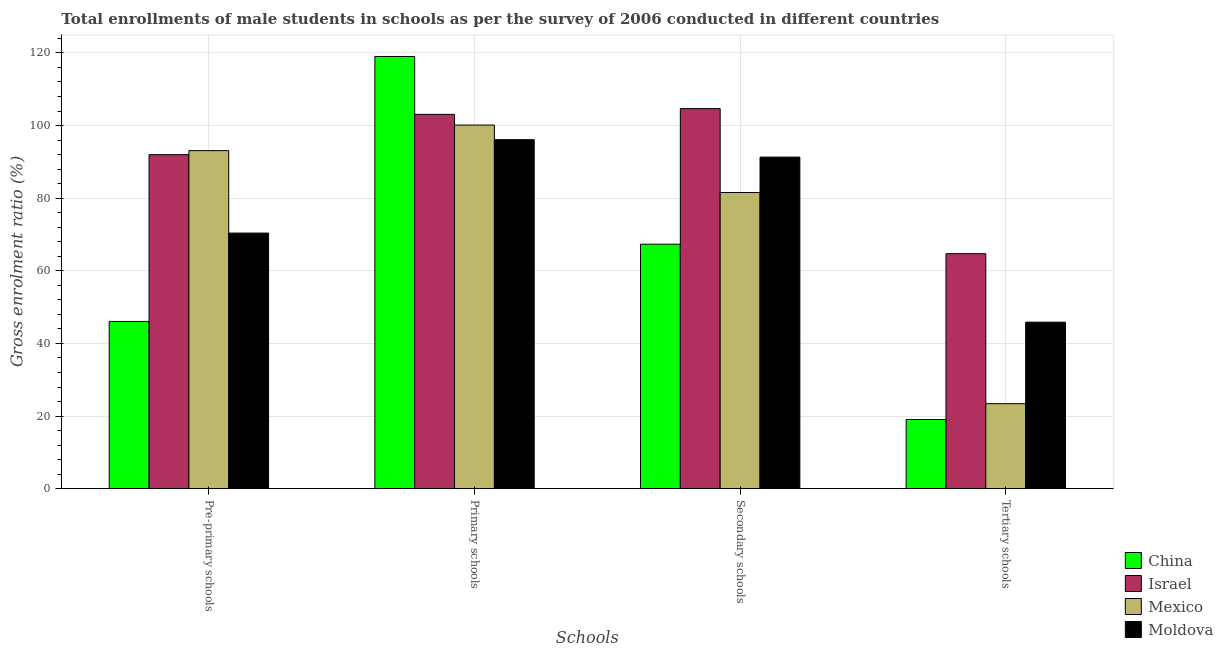How many different coloured bars are there?
Your answer should be compact. 4. How many groups of bars are there?
Keep it short and to the point. 4. Are the number of bars per tick equal to the number of legend labels?
Your answer should be very brief. Yes. Are the number of bars on each tick of the X-axis equal?
Keep it short and to the point. Yes. How many bars are there on the 4th tick from the right?
Ensure brevity in your answer.  4. What is the label of the 3rd group of bars from the left?
Your response must be concise. Secondary schools. What is the gross enrolment ratio(male) in pre-primary schools in China?
Your answer should be compact. 46.05. Across all countries, what is the maximum gross enrolment ratio(male) in primary schools?
Offer a very short reply. 119.02. Across all countries, what is the minimum gross enrolment ratio(male) in tertiary schools?
Offer a terse response. 19.05. What is the total gross enrolment ratio(male) in secondary schools in the graph?
Offer a very short reply. 344.88. What is the difference between the gross enrolment ratio(male) in pre-primary schools in Mexico and that in China?
Make the answer very short. 47.04. What is the difference between the gross enrolment ratio(male) in primary schools in Israel and the gross enrolment ratio(male) in tertiary schools in China?
Your response must be concise. 84.03. What is the average gross enrolment ratio(male) in primary schools per country?
Your answer should be compact. 104.59. What is the difference between the gross enrolment ratio(male) in tertiary schools and gross enrolment ratio(male) in pre-primary schools in Moldova?
Offer a terse response. -24.53. What is the ratio of the gross enrolment ratio(male) in secondary schools in Moldova to that in Israel?
Give a very brief answer. 0.87. Is the gross enrolment ratio(male) in secondary schools in Mexico less than that in China?
Keep it short and to the point. No. Is the difference between the gross enrolment ratio(male) in primary schools in Moldova and China greater than the difference between the gross enrolment ratio(male) in tertiary schools in Moldova and China?
Offer a very short reply. No. What is the difference between the highest and the second highest gross enrolment ratio(male) in primary schools?
Your answer should be very brief. 15.94. What is the difference between the highest and the lowest gross enrolment ratio(male) in secondary schools?
Provide a succinct answer. 37.34. In how many countries, is the gross enrolment ratio(male) in primary schools greater than the average gross enrolment ratio(male) in primary schools taken over all countries?
Offer a terse response. 1. Is the sum of the gross enrolment ratio(male) in tertiary schools in Moldova and Mexico greater than the maximum gross enrolment ratio(male) in secondary schools across all countries?
Your answer should be compact. No. Is it the case that in every country, the sum of the gross enrolment ratio(male) in tertiary schools and gross enrolment ratio(male) in primary schools is greater than the sum of gross enrolment ratio(male) in secondary schools and gross enrolment ratio(male) in pre-primary schools?
Ensure brevity in your answer.  Yes. What does the 3rd bar from the right in Primary schools represents?
Your response must be concise. Israel. Is it the case that in every country, the sum of the gross enrolment ratio(male) in pre-primary schools and gross enrolment ratio(male) in primary schools is greater than the gross enrolment ratio(male) in secondary schools?
Offer a terse response. Yes. How many bars are there?
Keep it short and to the point. 16. Are all the bars in the graph horizontal?
Make the answer very short. No. How many countries are there in the graph?
Provide a succinct answer. 4. Does the graph contain any zero values?
Provide a short and direct response. No. How many legend labels are there?
Ensure brevity in your answer.  4. How are the legend labels stacked?
Offer a terse response. Vertical. What is the title of the graph?
Ensure brevity in your answer.  Total enrollments of male students in schools as per the survey of 2006 conducted in different countries. Does "Sri Lanka" appear as one of the legend labels in the graph?
Offer a terse response. No. What is the label or title of the X-axis?
Offer a very short reply. Schools. What is the Gross enrolment ratio (%) in China in Pre-primary schools?
Your answer should be very brief. 46.05. What is the Gross enrolment ratio (%) of Israel in Pre-primary schools?
Provide a succinct answer. 91.99. What is the Gross enrolment ratio (%) of Mexico in Pre-primary schools?
Ensure brevity in your answer.  93.1. What is the Gross enrolment ratio (%) in Moldova in Pre-primary schools?
Keep it short and to the point. 70.39. What is the Gross enrolment ratio (%) in China in Primary schools?
Offer a terse response. 119.02. What is the Gross enrolment ratio (%) in Israel in Primary schools?
Keep it short and to the point. 103.08. What is the Gross enrolment ratio (%) in Mexico in Primary schools?
Your answer should be compact. 100.14. What is the Gross enrolment ratio (%) of Moldova in Primary schools?
Offer a terse response. 96.12. What is the Gross enrolment ratio (%) in China in Secondary schools?
Your answer should be very brief. 67.33. What is the Gross enrolment ratio (%) in Israel in Secondary schools?
Keep it short and to the point. 104.67. What is the Gross enrolment ratio (%) of Mexico in Secondary schools?
Offer a terse response. 81.57. What is the Gross enrolment ratio (%) in Moldova in Secondary schools?
Ensure brevity in your answer.  91.31. What is the Gross enrolment ratio (%) in China in Tertiary schools?
Offer a very short reply. 19.05. What is the Gross enrolment ratio (%) of Israel in Tertiary schools?
Provide a short and direct response. 64.71. What is the Gross enrolment ratio (%) in Mexico in Tertiary schools?
Offer a terse response. 23.41. What is the Gross enrolment ratio (%) of Moldova in Tertiary schools?
Provide a short and direct response. 45.85. Across all Schools, what is the maximum Gross enrolment ratio (%) in China?
Ensure brevity in your answer.  119.02. Across all Schools, what is the maximum Gross enrolment ratio (%) in Israel?
Keep it short and to the point. 104.67. Across all Schools, what is the maximum Gross enrolment ratio (%) of Mexico?
Provide a short and direct response. 100.14. Across all Schools, what is the maximum Gross enrolment ratio (%) of Moldova?
Provide a short and direct response. 96.12. Across all Schools, what is the minimum Gross enrolment ratio (%) of China?
Offer a terse response. 19.05. Across all Schools, what is the minimum Gross enrolment ratio (%) of Israel?
Provide a succinct answer. 64.71. Across all Schools, what is the minimum Gross enrolment ratio (%) of Mexico?
Ensure brevity in your answer.  23.41. Across all Schools, what is the minimum Gross enrolment ratio (%) of Moldova?
Your response must be concise. 45.85. What is the total Gross enrolment ratio (%) of China in the graph?
Offer a very short reply. 251.45. What is the total Gross enrolment ratio (%) in Israel in the graph?
Offer a terse response. 364.45. What is the total Gross enrolment ratio (%) in Mexico in the graph?
Give a very brief answer. 298.22. What is the total Gross enrolment ratio (%) of Moldova in the graph?
Your response must be concise. 303.67. What is the difference between the Gross enrolment ratio (%) of China in Pre-primary schools and that in Primary schools?
Make the answer very short. -72.97. What is the difference between the Gross enrolment ratio (%) in Israel in Pre-primary schools and that in Primary schools?
Keep it short and to the point. -11.1. What is the difference between the Gross enrolment ratio (%) of Mexico in Pre-primary schools and that in Primary schools?
Offer a very short reply. -7.04. What is the difference between the Gross enrolment ratio (%) of Moldova in Pre-primary schools and that in Primary schools?
Keep it short and to the point. -25.73. What is the difference between the Gross enrolment ratio (%) in China in Pre-primary schools and that in Secondary schools?
Your answer should be very brief. -21.27. What is the difference between the Gross enrolment ratio (%) in Israel in Pre-primary schools and that in Secondary schools?
Keep it short and to the point. -12.68. What is the difference between the Gross enrolment ratio (%) of Mexico in Pre-primary schools and that in Secondary schools?
Offer a terse response. 11.53. What is the difference between the Gross enrolment ratio (%) of Moldova in Pre-primary schools and that in Secondary schools?
Provide a short and direct response. -20.93. What is the difference between the Gross enrolment ratio (%) of China in Pre-primary schools and that in Tertiary schools?
Give a very brief answer. 27. What is the difference between the Gross enrolment ratio (%) of Israel in Pre-primary schools and that in Tertiary schools?
Ensure brevity in your answer.  27.27. What is the difference between the Gross enrolment ratio (%) of Mexico in Pre-primary schools and that in Tertiary schools?
Provide a succinct answer. 69.69. What is the difference between the Gross enrolment ratio (%) of Moldova in Pre-primary schools and that in Tertiary schools?
Offer a very short reply. 24.53. What is the difference between the Gross enrolment ratio (%) in China in Primary schools and that in Secondary schools?
Give a very brief answer. 51.7. What is the difference between the Gross enrolment ratio (%) of Israel in Primary schools and that in Secondary schools?
Ensure brevity in your answer.  -1.59. What is the difference between the Gross enrolment ratio (%) of Mexico in Primary schools and that in Secondary schools?
Provide a succinct answer. 18.57. What is the difference between the Gross enrolment ratio (%) in Moldova in Primary schools and that in Secondary schools?
Your response must be concise. 4.81. What is the difference between the Gross enrolment ratio (%) of China in Primary schools and that in Tertiary schools?
Offer a very short reply. 99.97. What is the difference between the Gross enrolment ratio (%) of Israel in Primary schools and that in Tertiary schools?
Ensure brevity in your answer.  38.37. What is the difference between the Gross enrolment ratio (%) in Mexico in Primary schools and that in Tertiary schools?
Make the answer very short. 76.73. What is the difference between the Gross enrolment ratio (%) in Moldova in Primary schools and that in Tertiary schools?
Provide a succinct answer. 50.27. What is the difference between the Gross enrolment ratio (%) of China in Secondary schools and that in Tertiary schools?
Keep it short and to the point. 48.28. What is the difference between the Gross enrolment ratio (%) in Israel in Secondary schools and that in Tertiary schools?
Offer a very short reply. 39.95. What is the difference between the Gross enrolment ratio (%) of Mexico in Secondary schools and that in Tertiary schools?
Provide a succinct answer. 58.16. What is the difference between the Gross enrolment ratio (%) in Moldova in Secondary schools and that in Tertiary schools?
Give a very brief answer. 45.46. What is the difference between the Gross enrolment ratio (%) of China in Pre-primary schools and the Gross enrolment ratio (%) of Israel in Primary schools?
Provide a short and direct response. -57.03. What is the difference between the Gross enrolment ratio (%) in China in Pre-primary schools and the Gross enrolment ratio (%) in Mexico in Primary schools?
Your answer should be very brief. -54.09. What is the difference between the Gross enrolment ratio (%) in China in Pre-primary schools and the Gross enrolment ratio (%) in Moldova in Primary schools?
Your answer should be compact. -50.06. What is the difference between the Gross enrolment ratio (%) in Israel in Pre-primary schools and the Gross enrolment ratio (%) in Mexico in Primary schools?
Your response must be concise. -8.16. What is the difference between the Gross enrolment ratio (%) of Israel in Pre-primary schools and the Gross enrolment ratio (%) of Moldova in Primary schools?
Offer a very short reply. -4.13. What is the difference between the Gross enrolment ratio (%) in Mexico in Pre-primary schools and the Gross enrolment ratio (%) in Moldova in Primary schools?
Offer a terse response. -3.02. What is the difference between the Gross enrolment ratio (%) of China in Pre-primary schools and the Gross enrolment ratio (%) of Israel in Secondary schools?
Ensure brevity in your answer.  -58.61. What is the difference between the Gross enrolment ratio (%) in China in Pre-primary schools and the Gross enrolment ratio (%) in Mexico in Secondary schools?
Offer a very short reply. -35.51. What is the difference between the Gross enrolment ratio (%) in China in Pre-primary schools and the Gross enrolment ratio (%) in Moldova in Secondary schools?
Make the answer very short. -45.26. What is the difference between the Gross enrolment ratio (%) in Israel in Pre-primary schools and the Gross enrolment ratio (%) in Mexico in Secondary schools?
Your answer should be very brief. 10.42. What is the difference between the Gross enrolment ratio (%) of Israel in Pre-primary schools and the Gross enrolment ratio (%) of Moldova in Secondary schools?
Provide a short and direct response. 0.67. What is the difference between the Gross enrolment ratio (%) in Mexico in Pre-primary schools and the Gross enrolment ratio (%) in Moldova in Secondary schools?
Offer a very short reply. 1.78. What is the difference between the Gross enrolment ratio (%) in China in Pre-primary schools and the Gross enrolment ratio (%) in Israel in Tertiary schools?
Give a very brief answer. -18.66. What is the difference between the Gross enrolment ratio (%) of China in Pre-primary schools and the Gross enrolment ratio (%) of Mexico in Tertiary schools?
Provide a short and direct response. 22.64. What is the difference between the Gross enrolment ratio (%) in China in Pre-primary schools and the Gross enrolment ratio (%) in Moldova in Tertiary schools?
Your answer should be compact. 0.2. What is the difference between the Gross enrolment ratio (%) in Israel in Pre-primary schools and the Gross enrolment ratio (%) in Mexico in Tertiary schools?
Offer a terse response. 68.58. What is the difference between the Gross enrolment ratio (%) of Israel in Pre-primary schools and the Gross enrolment ratio (%) of Moldova in Tertiary schools?
Make the answer very short. 46.13. What is the difference between the Gross enrolment ratio (%) of Mexico in Pre-primary schools and the Gross enrolment ratio (%) of Moldova in Tertiary schools?
Your answer should be very brief. 47.24. What is the difference between the Gross enrolment ratio (%) of China in Primary schools and the Gross enrolment ratio (%) of Israel in Secondary schools?
Your response must be concise. 14.35. What is the difference between the Gross enrolment ratio (%) of China in Primary schools and the Gross enrolment ratio (%) of Mexico in Secondary schools?
Provide a succinct answer. 37.45. What is the difference between the Gross enrolment ratio (%) in China in Primary schools and the Gross enrolment ratio (%) in Moldova in Secondary schools?
Give a very brief answer. 27.71. What is the difference between the Gross enrolment ratio (%) of Israel in Primary schools and the Gross enrolment ratio (%) of Mexico in Secondary schools?
Provide a succinct answer. 21.51. What is the difference between the Gross enrolment ratio (%) of Israel in Primary schools and the Gross enrolment ratio (%) of Moldova in Secondary schools?
Your response must be concise. 11.77. What is the difference between the Gross enrolment ratio (%) in Mexico in Primary schools and the Gross enrolment ratio (%) in Moldova in Secondary schools?
Provide a succinct answer. 8.83. What is the difference between the Gross enrolment ratio (%) of China in Primary schools and the Gross enrolment ratio (%) of Israel in Tertiary schools?
Make the answer very short. 54.31. What is the difference between the Gross enrolment ratio (%) in China in Primary schools and the Gross enrolment ratio (%) in Mexico in Tertiary schools?
Your response must be concise. 95.61. What is the difference between the Gross enrolment ratio (%) of China in Primary schools and the Gross enrolment ratio (%) of Moldova in Tertiary schools?
Make the answer very short. 73.17. What is the difference between the Gross enrolment ratio (%) of Israel in Primary schools and the Gross enrolment ratio (%) of Mexico in Tertiary schools?
Offer a terse response. 79.67. What is the difference between the Gross enrolment ratio (%) of Israel in Primary schools and the Gross enrolment ratio (%) of Moldova in Tertiary schools?
Offer a very short reply. 57.23. What is the difference between the Gross enrolment ratio (%) in Mexico in Primary schools and the Gross enrolment ratio (%) in Moldova in Tertiary schools?
Provide a succinct answer. 54.29. What is the difference between the Gross enrolment ratio (%) of China in Secondary schools and the Gross enrolment ratio (%) of Israel in Tertiary schools?
Ensure brevity in your answer.  2.61. What is the difference between the Gross enrolment ratio (%) in China in Secondary schools and the Gross enrolment ratio (%) in Mexico in Tertiary schools?
Your answer should be very brief. 43.92. What is the difference between the Gross enrolment ratio (%) of China in Secondary schools and the Gross enrolment ratio (%) of Moldova in Tertiary schools?
Keep it short and to the point. 21.47. What is the difference between the Gross enrolment ratio (%) in Israel in Secondary schools and the Gross enrolment ratio (%) in Mexico in Tertiary schools?
Offer a terse response. 81.26. What is the difference between the Gross enrolment ratio (%) in Israel in Secondary schools and the Gross enrolment ratio (%) in Moldova in Tertiary schools?
Make the answer very short. 58.81. What is the difference between the Gross enrolment ratio (%) in Mexico in Secondary schools and the Gross enrolment ratio (%) in Moldova in Tertiary schools?
Keep it short and to the point. 35.72. What is the average Gross enrolment ratio (%) of China per Schools?
Make the answer very short. 62.86. What is the average Gross enrolment ratio (%) of Israel per Schools?
Ensure brevity in your answer.  91.11. What is the average Gross enrolment ratio (%) of Mexico per Schools?
Your response must be concise. 74.55. What is the average Gross enrolment ratio (%) in Moldova per Schools?
Your answer should be compact. 75.92. What is the difference between the Gross enrolment ratio (%) of China and Gross enrolment ratio (%) of Israel in Pre-primary schools?
Give a very brief answer. -45.93. What is the difference between the Gross enrolment ratio (%) in China and Gross enrolment ratio (%) in Mexico in Pre-primary schools?
Offer a terse response. -47.04. What is the difference between the Gross enrolment ratio (%) in China and Gross enrolment ratio (%) in Moldova in Pre-primary schools?
Offer a very short reply. -24.33. What is the difference between the Gross enrolment ratio (%) of Israel and Gross enrolment ratio (%) of Mexico in Pre-primary schools?
Your answer should be very brief. -1.11. What is the difference between the Gross enrolment ratio (%) of Israel and Gross enrolment ratio (%) of Moldova in Pre-primary schools?
Offer a terse response. 21.6. What is the difference between the Gross enrolment ratio (%) in Mexico and Gross enrolment ratio (%) in Moldova in Pre-primary schools?
Keep it short and to the point. 22.71. What is the difference between the Gross enrolment ratio (%) of China and Gross enrolment ratio (%) of Israel in Primary schools?
Your answer should be very brief. 15.94. What is the difference between the Gross enrolment ratio (%) in China and Gross enrolment ratio (%) in Mexico in Primary schools?
Offer a very short reply. 18.88. What is the difference between the Gross enrolment ratio (%) of China and Gross enrolment ratio (%) of Moldova in Primary schools?
Offer a very short reply. 22.9. What is the difference between the Gross enrolment ratio (%) of Israel and Gross enrolment ratio (%) of Mexico in Primary schools?
Your answer should be compact. 2.94. What is the difference between the Gross enrolment ratio (%) of Israel and Gross enrolment ratio (%) of Moldova in Primary schools?
Provide a short and direct response. 6.96. What is the difference between the Gross enrolment ratio (%) of Mexico and Gross enrolment ratio (%) of Moldova in Primary schools?
Make the answer very short. 4.02. What is the difference between the Gross enrolment ratio (%) in China and Gross enrolment ratio (%) in Israel in Secondary schools?
Your answer should be compact. -37.34. What is the difference between the Gross enrolment ratio (%) of China and Gross enrolment ratio (%) of Mexico in Secondary schools?
Make the answer very short. -14.24. What is the difference between the Gross enrolment ratio (%) of China and Gross enrolment ratio (%) of Moldova in Secondary schools?
Give a very brief answer. -23.99. What is the difference between the Gross enrolment ratio (%) in Israel and Gross enrolment ratio (%) in Mexico in Secondary schools?
Your answer should be compact. 23.1. What is the difference between the Gross enrolment ratio (%) in Israel and Gross enrolment ratio (%) in Moldova in Secondary schools?
Your answer should be compact. 13.36. What is the difference between the Gross enrolment ratio (%) in Mexico and Gross enrolment ratio (%) in Moldova in Secondary schools?
Give a very brief answer. -9.74. What is the difference between the Gross enrolment ratio (%) in China and Gross enrolment ratio (%) in Israel in Tertiary schools?
Offer a very short reply. -45.66. What is the difference between the Gross enrolment ratio (%) in China and Gross enrolment ratio (%) in Mexico in Tertiary schools?
Make the answer very short. -4.36. What is the difference between the Gross enrolment ratio (%) in China and Gross enrolment ratio (%) in Moldova in Tertiary schools?
Ensure brevity in your answer.  -26.8. What is the difference between the Gross enrolment ratio (%) of Israel and Gross enrolment ratio (%) of Mexico in Tertiary schools?
Your response must be concise. 41.3. What is the difference between the Gross enrolment ratio (%) of Israel and Gross enrolment ratio (%) of Moldova in Tertiary schools?
Make the answer very short. 18.86. What is the difference between the Gross enrolment ratio (%) in Mexico and Gross enrolment ratio (%) in Moldova in Tertiary schools?
Keep it short and to the point. -22.44. What is the ratio of the Gross enrolment ratio (%) of China in Pre-primary schools to that in Primary schools?
Your answer should be very brief. 0.39. What is the ratio of the Gross enrolment ratio (%) in Israel in Pre-primary schools to that in Primary schools?
Give a very brief answer. 0.89. What is the ratio of the Gross enrolment ratio (%) of Mexico in Pre-primary schools to that in Primary schools?
Your answer should be very brief. 0.93. What is the ratio of the Gross enrolment ratio (%) in Moldova in Pre-primary schools to that in Primary schools?
Your answer should be very brief. 0.73. What is the ratio of the Gross enrolment ratio (%) of China in Pre-primary schools to that in Secondary schools?
Your answer should be very brief. 0.68. What is the ratio of the Gross enrolment ratio (%) of Israel in Pre-primary schools to that in Secondary schools?
Provide a short and direct response. 0.88. What is the ratio of the Gross enrolment ratio (%) in Mexico in Pre-primary schools to that in Secondary schools?
Provide a succinct answer. 1.14. What is the ratio of the Gross enrolment ratio (%) of Moldova in Pre-primary schools to that in Secondary schools?
Keep it short and to the point. 0.77. What is the ratio of the Gross enrolment ratio (%) of China in Pre-primary schools to that in Tertiary schools?
Your answer should be very brief. 2.42. What is the ratio of the Gross enrolment ratio (%) of Israel in Pre-primary schools to that in Tertiary schools?
Your answer should be very brief. 1.42. What is the ratio of the Gross enrolment ratio (%) of Mexico in Pre-primary schools to that in Tertiary schools?
Provide a succinct answer. 3.98. What is the ratio of the Gross enrolment ratio (%) of Moldova in Pre-primary schools to that in Tertiary schools?
Keep it short and to the point. 1.53. What is the ratio of the Gross enrolment ratio (%) in China in Primary schools to that in Secondary schools?
Your answer should be compact. 1.77. What is the ratio of the Gross enrolment ratio (%) of Mexico in Primary schools to that in Secondary schools?
Ensure brevity in your answer.  1.23. What is the ratio of the Gross enrolment ratio (%) of Moldova in Primary schools to that in Secondary schools?
Your answer should be compact. 1.05. What is the ratio of the Gross enrolment ratio (%) of China in Primary schools to that in Tertiary schools?
Ensure brevity in your answer.  6.25. What is the ratio of the Gross enrolment ratio (%) of Israel in Primary schools to that in Tertiary schools?
Keep it short and to the point. 1.59. What is the ratio of the Gross enrolment ratio (%) in Mexico in Primary schools to that in Tertiary schools?
Offer a very short reply. 4.28. What is the ratio of the Gross enrolment ratio (%) of Moldova in Primary schools to that in Tertiary schools?
Ensure brevity in your answer.  2.1. What is the ratio of the Gross enrolment ratio (%) in China in Secondary schools to that in Tertiary schools?
Offer a very short reply. 3.53. What is the ratio of the Gross enrolment ratio (%) of Israel in Secondary schools to that in Tertiary schools?
Your response must be concise. 1.62. What is the ratio of the Gross enrolment ratio (%) in Mexico in Secondary schools to that in Tertiary schools?
Keep it short and to the point. 3.48. What is the ratio of the Gross enrolment ratio (%) in Moldova in Secondary schools to that in Tertiary schools?
Offer a terse response. 1.99. What is the difference between the highest and the second highest Gross enrolment ratio (%) in China?
Make the answer very short. 51.7. What is the difference between the highest and the second highest Gross enrolment ratio (%) of Israel?
Keep it short and to the point. 1.59. What is the difference between the highest and the second highest Gross enrolment ratio (%) of Mexico?
Your answer should be compact. 7.04. What is the difference between the highest and the second highest Gross enrolment ratio (%) in Moldova?
Your answer should be compact. 4.81. What is the difference between the highest and the lowest Gross enrolment ratio (%) in China?
Your answer should be very brief. 99.97. What is the difference between the highest and the lowest Gross enrolment ratio (%) of Israel?
Your answer should be very brief. 39.95. What is the difference between the highest and the lowest Gross enrolment ratio (%) in Mexico?
Provide a succinct answer. 76.73. What is the difference between the highest and the lowest Gross enrolment ratio (%) of Moldova?
Make the answer very short. 50.27. 